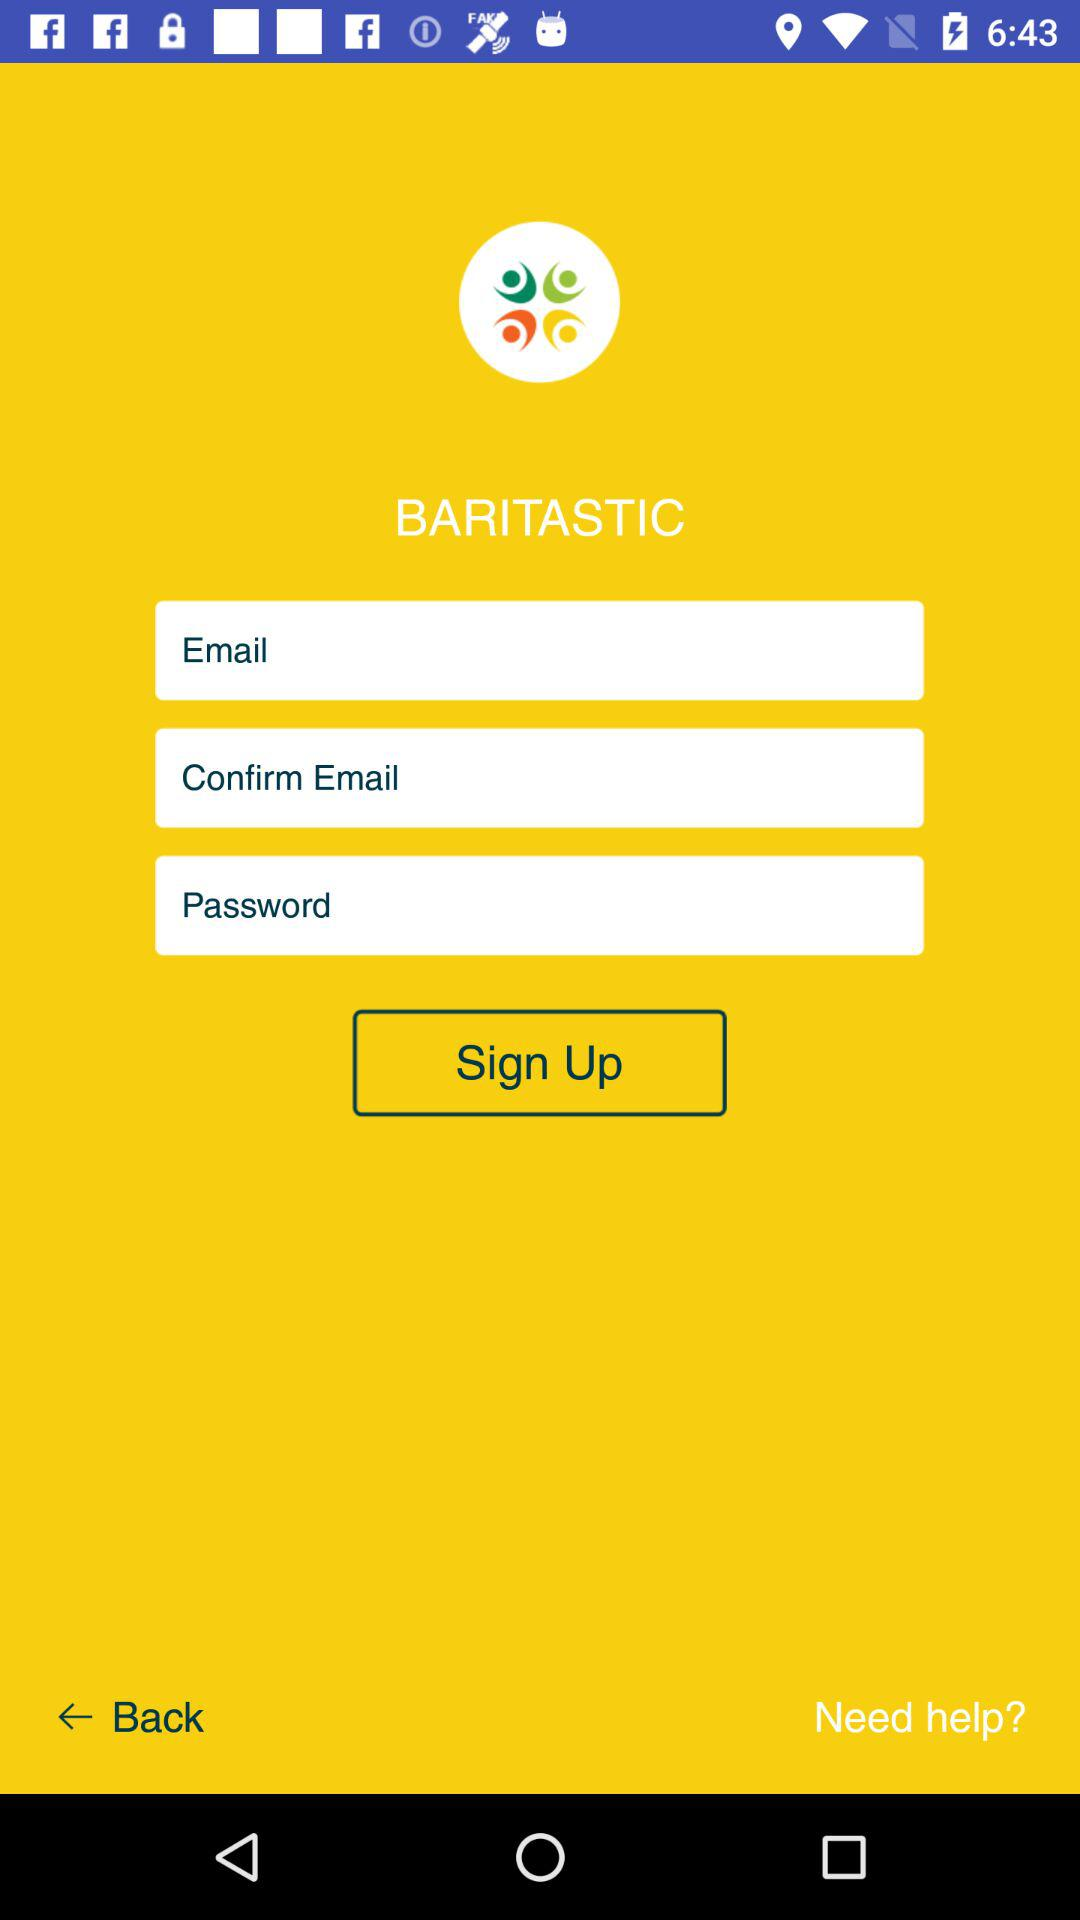What is the application name? The application name is "BARITASTIC". 